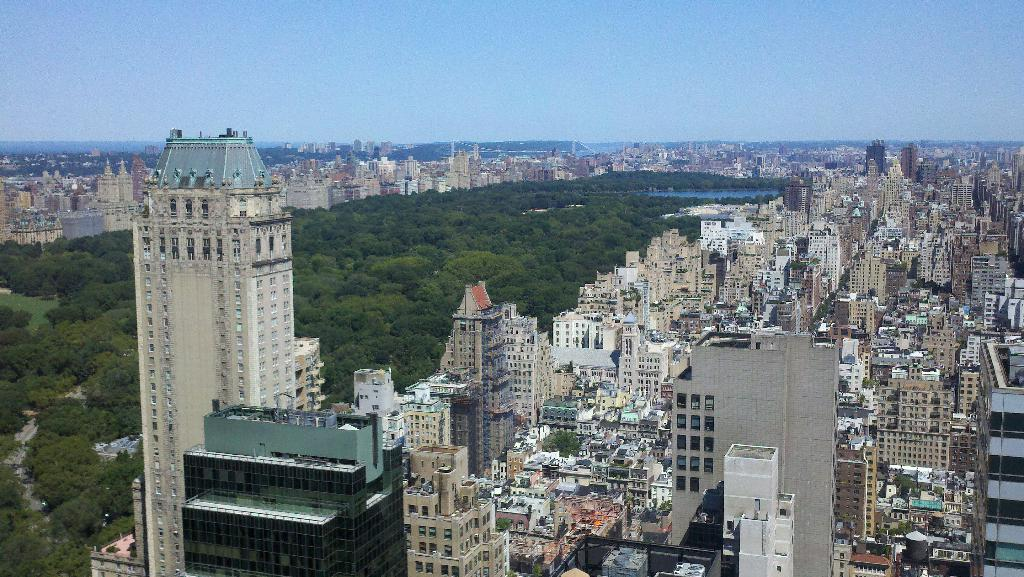What type of view is shown in the image? The image is an aerial view of a city. What can be seen on the left and right sides of the image? There are buildings on either side of the image. What is located in the middle of the image? There are trees in the middle of the image. What is visible above the city in the image? The sky is visible above the city. What type of juice is being served in the image? There is no juice present in the image; it is an aerial view of a city. Can you describe the goose that is walking through the trees in the image? There is no goose present in the image; it features buildings, trees, and the sky. 